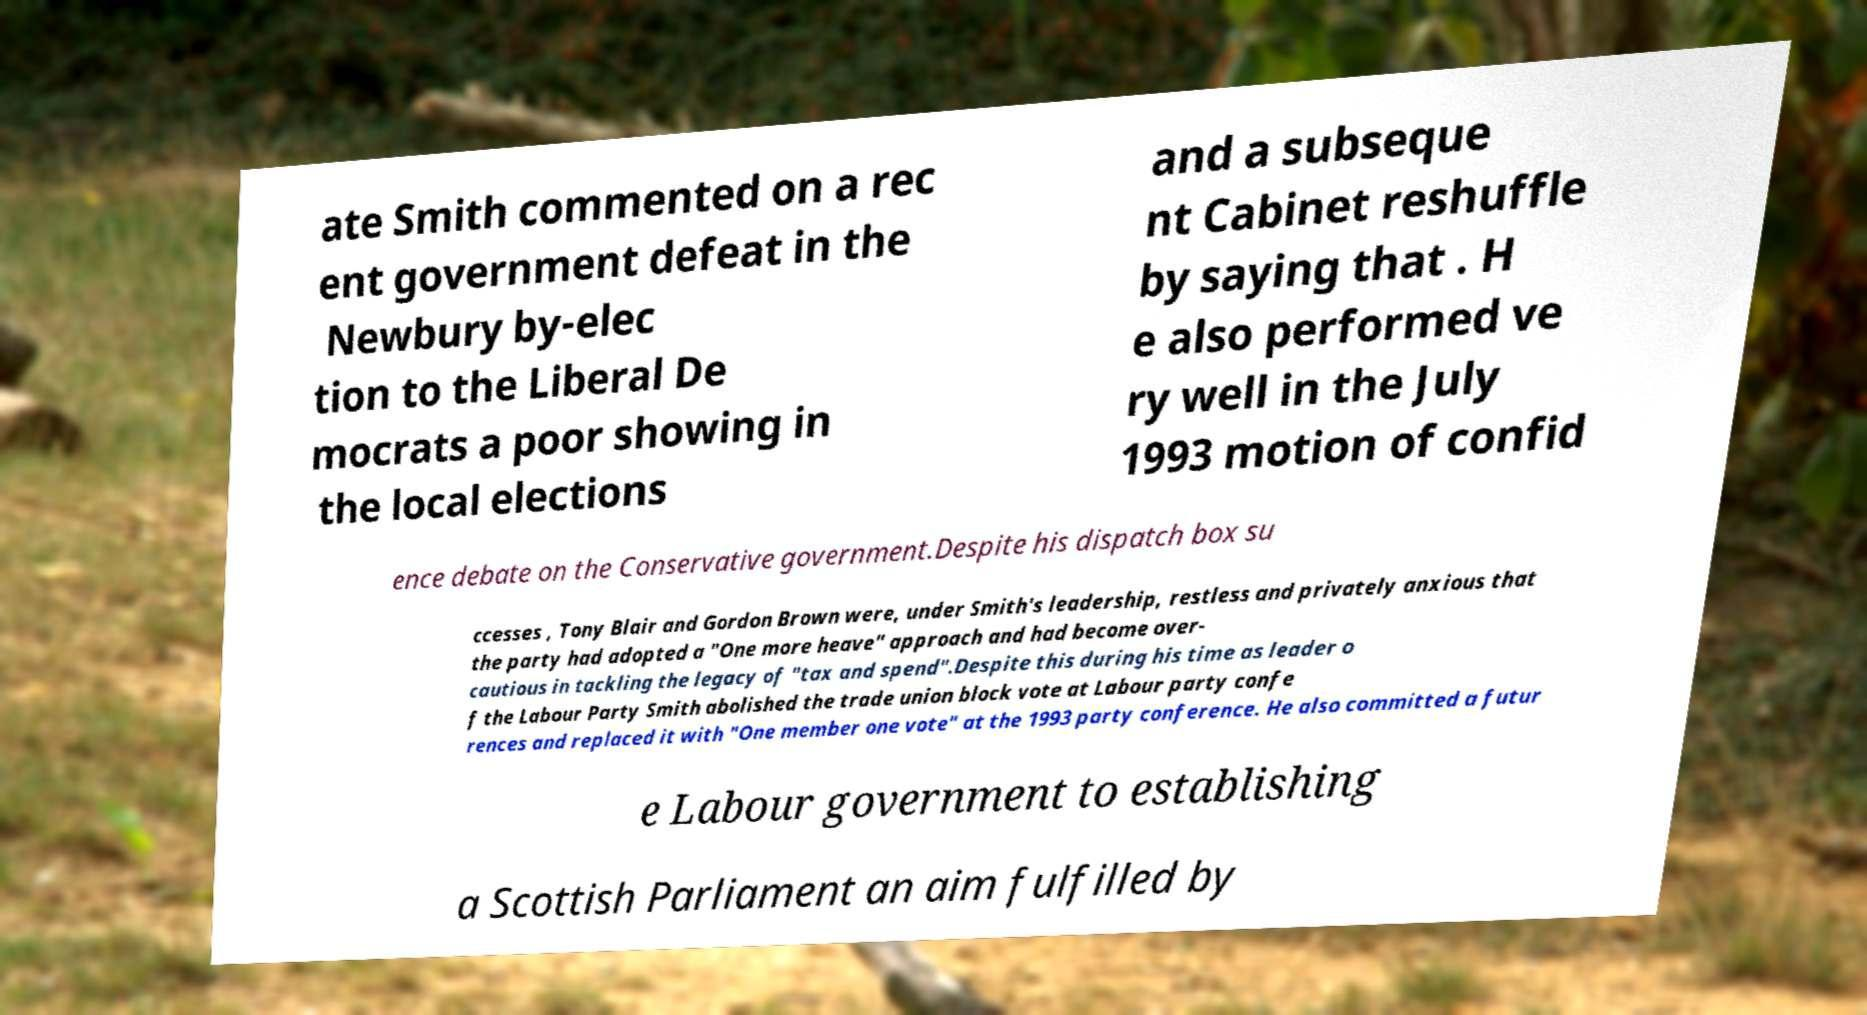What messages or text are displayed in this image? I need them in a readable, typed format. ate Smith commented on a rec ent government defeat in the Newbury by-elec tion to the Liberal De mocrats a poor showing in the local elections and a subseque nt Cabinet reshuffle by saying that . H e also performed ve ry well in the July 1993 motion of confid ence debate on the Conservative government.Despite his dispatch box su ccesses , Tony Blair and Gordon Brown were, under Smith's leadership, restless and privately anxious that the party had adopted a "One more heave" approach and had become over- cautious in tackling the legacy of "tax and spend".Despite this during his time as leader o f the Labour Party Smith abolished the trade union block vote at Labour party confe rences and replaced it with "One member one vote" at the 1993 party conference. He also committed a futur e Labour government to establishing a Scottish Parliament an aim fulfilled by 